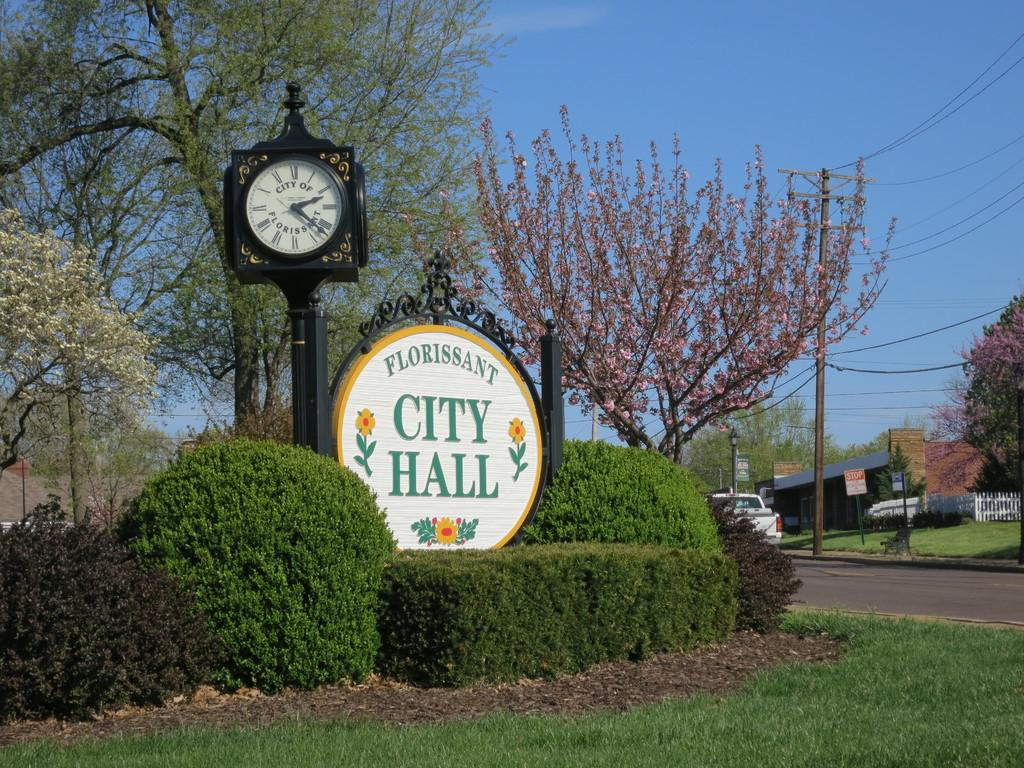<image>
Write a terse but informative summary of the picture. Hedges surround the sign for the Florissant City Hall. 